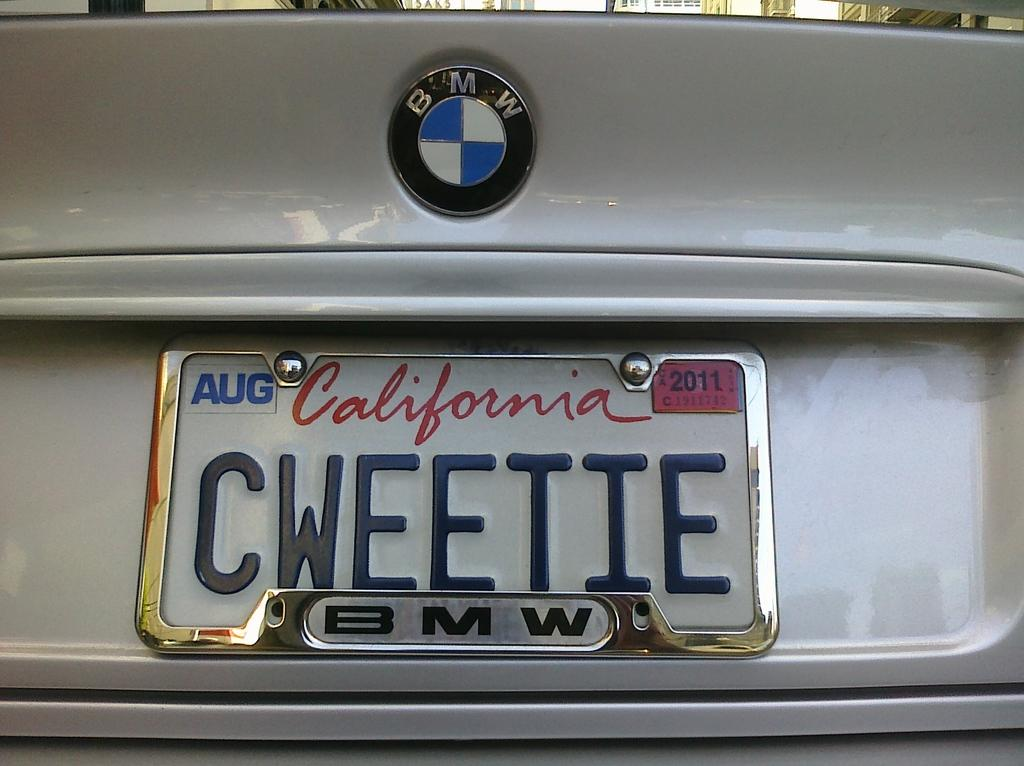Provide a one-sentence caption for the provided image. California license plate CWEETIE on a white BMW. 